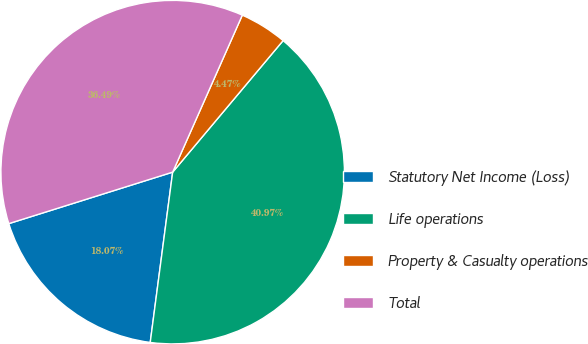Convert chart. <chart><loc_0><loc_0><loc_500><loc_500><pie_chart><fcel>Statutory Net Income (Loss)<fcel>Life operations<fcel>Property & Casualty operations<fcel>Total<nl><fcel>18.07%<fcel>40.97%<fcel>4.47%<fcel>36.49%<nl></chart> 